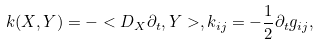Convert formula to latex. <formula><loc_0><loc_0><loc_500><loc_500>\\ k ( X , Y ) = - < D _ { X } \partial _ { t } , Y > , k _ { i j } = - \frac { 1 } { 2 } \partial _ { t } g _ { i j } , \\</formula> 